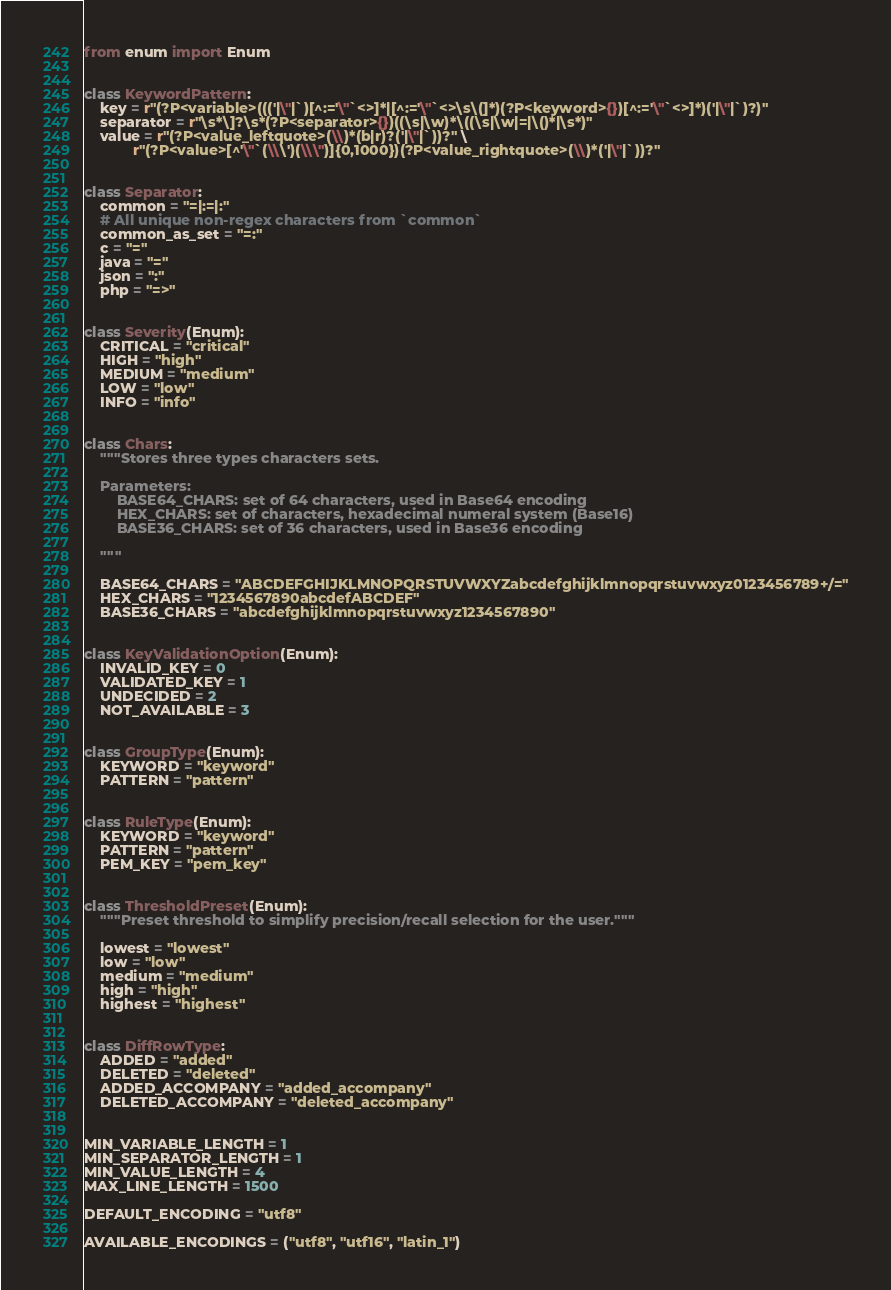Convert code to text. <code><loc_0><loc_0><loc_500><loc_500><_Python_>from enum import Enum


class KeywordPattern:
    key = r"(?P<variable>((('|\"|`)[^:='\"`<>]*|[^:='\"`<>\s\(]*)(?P<keyword>{})[^:='\"`<>]*)('|\"|`)?)"
    separator = r"\s*\]?\s*(?P<separator>{})((\s|\w)*\((\s|\w|=|\()*|\s*)"
    value = r"(?P<value_leftquote>(\\)*(b|r)?('|\"|`))?" \
            r"(?P<value>[^'\"`(\\\')(\\\")]{0,1000})(?P<value_rightquote>(\\)*('|\"|`))?"


class Separator:
    common = "=|:=|:"
    # All unique non-regex characters from `common`
    common_as_set = "=:"
    c = "="
    java = "="
    json = ":"
    php = "=>"


class Severity(Enum):
    CRITICAL = "critical"
    HIGH = "high"
    MEDIUM = "medium"
    LOW = "low"
    INFO = "info"


class Chars:
    """Stores three types characters sets.

    Parameters:
        BASE64_CHARS: set of 64 characters, used in Base64 encoding
        HEX_CHARS: set of characters, hexadecimal numeral system (Base16)
        BASE36_CHARS: set of 36 characters, used in Base36 encoding

    """

    BASE64_CHARS = "ABCDEFGHIJKLMNOPQRSTUVWXYZabcdefghijklmnopqrstuvwxyz0123456789+/="
    HEX_CHARS = "1234567890abcdefABCDEF"
    BASE36_CHARS = "abcdefghijklmnopqrstuvwxyz1234567890"


class KeyValidationOption(Enum):
    INVALID_KEY = 0
    VALIDATED_KEY = 1
    UNDECIDED = 2
    NOT_AVAILABLE = 3


class GroupType(Enum):
    KEYWORD = "keyword"
    PATTERN = "pattern"


class RuleType(Enum):
    KEYWORD = "keyword"
    PATTERN = "pattern"
    PEM_KEY = "pem_key"


class ThresholdPreset(Enum):
    """Preset threshold to simplify precision/recall selection for the user."""

    lowest = "lowest"
    low = "low"
    medium = "medium"
    high = "high"
    highest = "highest"


class DiffRowType:
    ADDED = "added"
    DELETED = "deleted"
    ADDED_ACCOMPANY = "added_accompany"
    DELETED_ACCOMPANY = "deleted_accompany"


MIN_VARIABLE_LENGTH = 1
MIN_SEPARATOR_LENGTH = 1
MIN_VALUE_LENGTH = 4
MAX_LINE_LENGTH = 1500

DEFAULT_ENCODING = "utf8"

AVAILABLE_ENCODINGS = ("utf8", "utf16", "latin_1")
</code> 